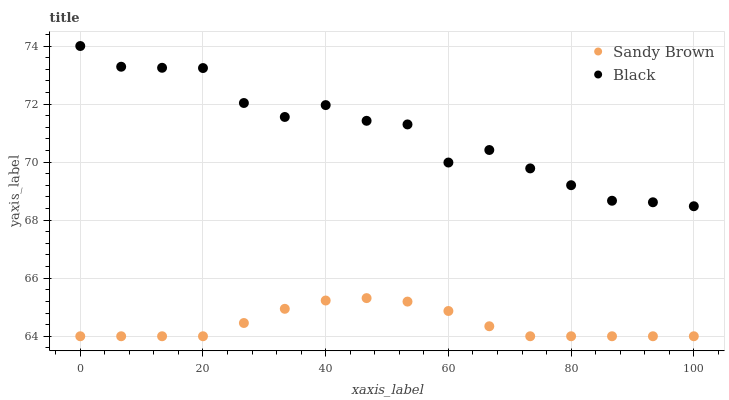Does Sandy Brown have the minimum area under the curve?
Answer yes or no. Yes. Does Black have the maximum area under the curve?
Answer yes or no. Yes. Does Sandy Brown have the maximum area under the curve?
Answer yes or no. No. Is Sandy Brown the smoothest?
Answer yes or no. Yes. Is Black the roughest?
Answer yes or no. Yes. Is Sandy Brown the roughest?
Answer yes or no. No. Does Sandy Brown have the lowest value?
Answer yes or no. Yes. Does Black have the highest value?
Answer yes or no. Yes. Does Sandy Brown have the highest value?
Answer yes or no. No. Is Sandy Brown less than Black?
Answer yes or no. Yes. Is Black greater than Sandy Brown?
Answer yes or no. Yes. Does Sandy Brown intersect Black?
Answer yes or no. No. 